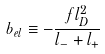Convert formula to latex. <formula><loc_0><loc_0><loc_500><loc_500>b _ { e l } \equiv - \frac { f l _ { D } ^ { 2 } } { l _ { - } + l _ { + } }</formula> 